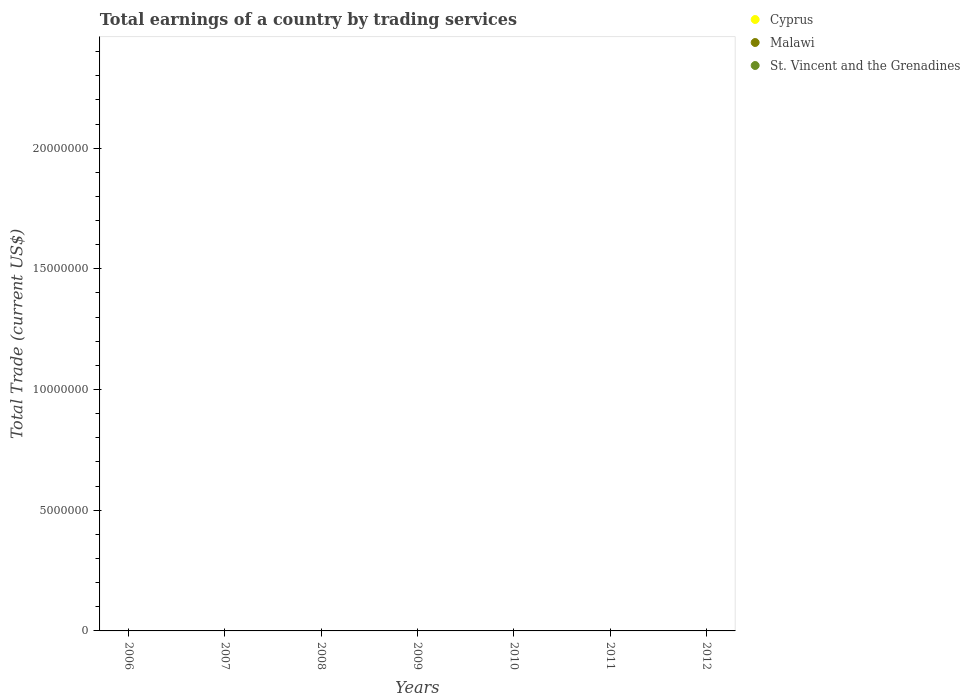How many different coloured dotlines are there?
Keep it short and to the point. 0. Across all years, what is the minimum total earnings in Cyprus?
Ensure brevity in your answer.  0. What is the total total earnings in Malawi in the graph?
Provide a short and direct response. 0. What is the difference between the total earnings in St. Vincent and the Grenadines in 2006 and the total earnings in Cyprus in 2009?
Give a very brief answer. 0. In how many years, is the total earnings in Malawi greater than 1000000 US$?
Keep it short and to the point. 0. In how many years, is the total earnings in Malawi greater than the average total earnings in Malawi taken over all years?
Your response must be concise. 0. Is it the case that in every year, the sum of the total earnings in St. Vincent and the Grenadines and total earnings in Cyprus  is greater than the total earnings in Malawi?
Provide a succinct answer. No. Is the total earnings in St. Vincent and the Grenadines strictly greater than the total earnings in Malawi over the years?
Provide a short and direct response. Yes. Is the total earnings in Malawi strictly less than the total earnings in St. Vincent and the Grenadines over the years?
Your answer should be very brief. Yes. How many years are there in the graph?
Ensure brevity in your answer.  7. Where does the legend appear in the graph?
Ensure brevity in your answer.  Top right. What is the title of the graph?
Provide a succinct answer. Total earnings of a country by trading services. What is the label or title of the X-axis?
Provide a succinct answer. Years. What is the label or title of the Y-axis?
Provide a succinct answer. Total Trade (current US$). What is the Total Trade (current US$) of Cyprus in 2006?
Your response must be concise. 0. What is the Total Trade (current US$) in St. Vincent and the Grenadines in 2007?
Keep it short and to the point. 0. What is the Total Trade (current US$) in Cyprus in 2009?
Ensure brevity in your answer.  0. What is the Total Trade (current US$) of Malawi in 2009?
Offer a very short reply. 0. What is the Total Trade (current US$) of St. Vincent and the Grenadines in 2009?
Provide a short and direct response. 0. What is the Total Trade (current US$) in Malawi in 2010?
Provide a succinct answer. 0. What is the Total Trade (current US$) of St. Vincent and the Grenadines in 2012?
Keep it short and to the point. 0. What is the total Total Trade (current US$) in Malawi in the graph?
Your response must be concise. 0. What is the total Total Trade (current US$) in St. Vincent and the Grenadines in the graph?
Your answer should be very brief. 0. What is the average Total Trade (current US$) of St. Vincent and the Grenadines per year?
Your answer should be compact. 0. 